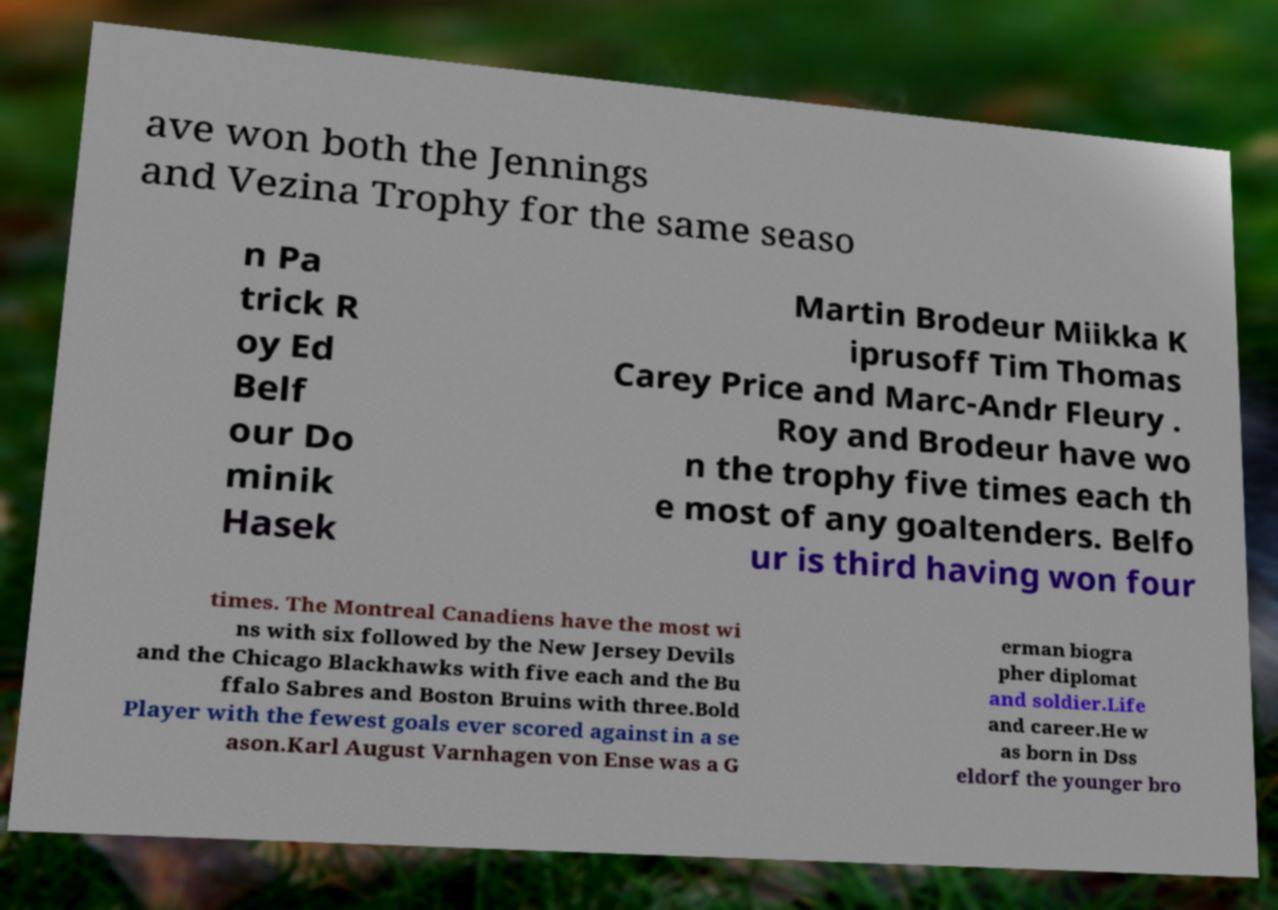Could you extract and type out the text from this image? ave won both the Jennings and Vezina Trophy for the same seaso n Pa trick R oy Ed Belf our Do minik Hasek Martin Brodeur Miikka K iprusoff Tim Thomas Carey Price and Marc-Andr Fleury . Roy and Brodeur have wo n the trophy five times each th e most of any goaltenders. Belfo ur is third having won four times. The Montreal Canadiens have the most wi ns with six followed by the New Jersey Devils and the Chicago Blackhawks with five each and the Bu ffalo Sabres and Boston Bruins with three.Bold Player with the fewest goals ever scored against in a se ason.Karl August Varnhagen von Ense was a G erman biogra pher diplomat and soldier.Life and career.He w as born in Dss eldorf the younger bro 